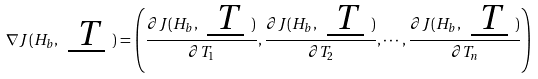<formula> <loc_0><loc_0><loc_500><loc_500>\nabla J ( H _ { b } , \emph { \underline { T } } ) = \left ( \frac { \partial { J } ( H _ { b } , \emph { \underline { T } } ) } { \partial { T _ { 1 } } } , \frac { \partial { J } ( H _ { b } , \emph { \underline { T } } ) } { \partial { T _ { 2 } } } , \cdots , \frac { \partial { J } ( H _ { b } , \emph { \underline { T } } ) } { \partial { T _ { n } } } \right )</formula> 